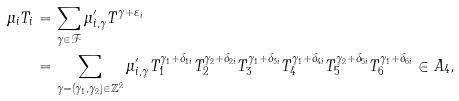<formula> <loc_0><loc_0><loc_500><loc_500>\mu _ { i } T _ { i } & = \sum _ { \gamma \in \mathcal { F } } \mu ^ { \prime } _ { i , \gamma } T ^ { \gamma + \varepsilon _ { i } } \\ & = \sum _ { \gamma = ( \gamma _ { 1 } , \gamma _ { 2 } ) \in \mathbb { Z } ^ { 2 } } \mu ^ { \prime } _ { i , \gamma } T _ { 1 } ^ { \gamma _ { 1 } + \delta _ { 1 i } } T _ { 2 } ^ { \gamma _ { 2 } + \delta _ { 2 i } } T _ { 3 } ^ { \gamma _ { 1 } + \delta _ { 3 i } } T _ { 4 } ^ { \gamma _ { 1 } + \delta _ { 4 i } } T _ { 5 } ^ { \gamma _ { 2 } + \delta _ { 5 i } } T _ { 6 } ^ { \gamma _ { 1 } + \delta _ { 6 i } } \in A _ { 4 } ,</formula> 